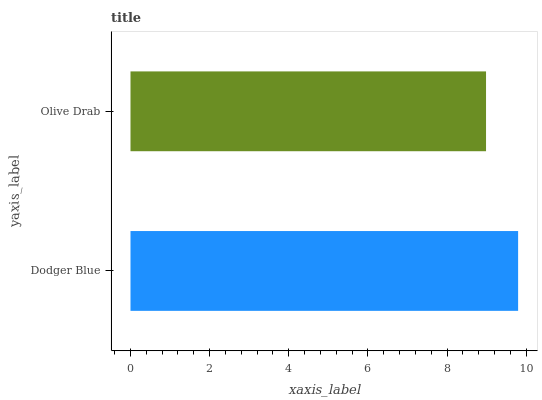Is Olive Drab the minimum?
Answer yes or no. Yes. Is Dodger Blue the maximum?
Answer yes or no. Yes. Is Olive Drab the maximum?
Answer yes or no. No. Is Dodger Blue greater than Olive Drab?
Answer yes or no. Yes. Is Olive Drab less than Dodger Blue?
Answer yes or no. Yes. Is Olive Drab greater than Dodger Blue?
Answer yes or no. No. Is Dodger Blue less than Olive Drab?
Answer yes or no. No. Is Dodger Blue the high median?
Answer yes or no. Yes. Is Olive Drab the low median?
Answer yes or no. Yes. Is Olive Drab the high median?
Answer yes or no. No. Is Dodger Blue the low median?
Answer yes or no. No. 